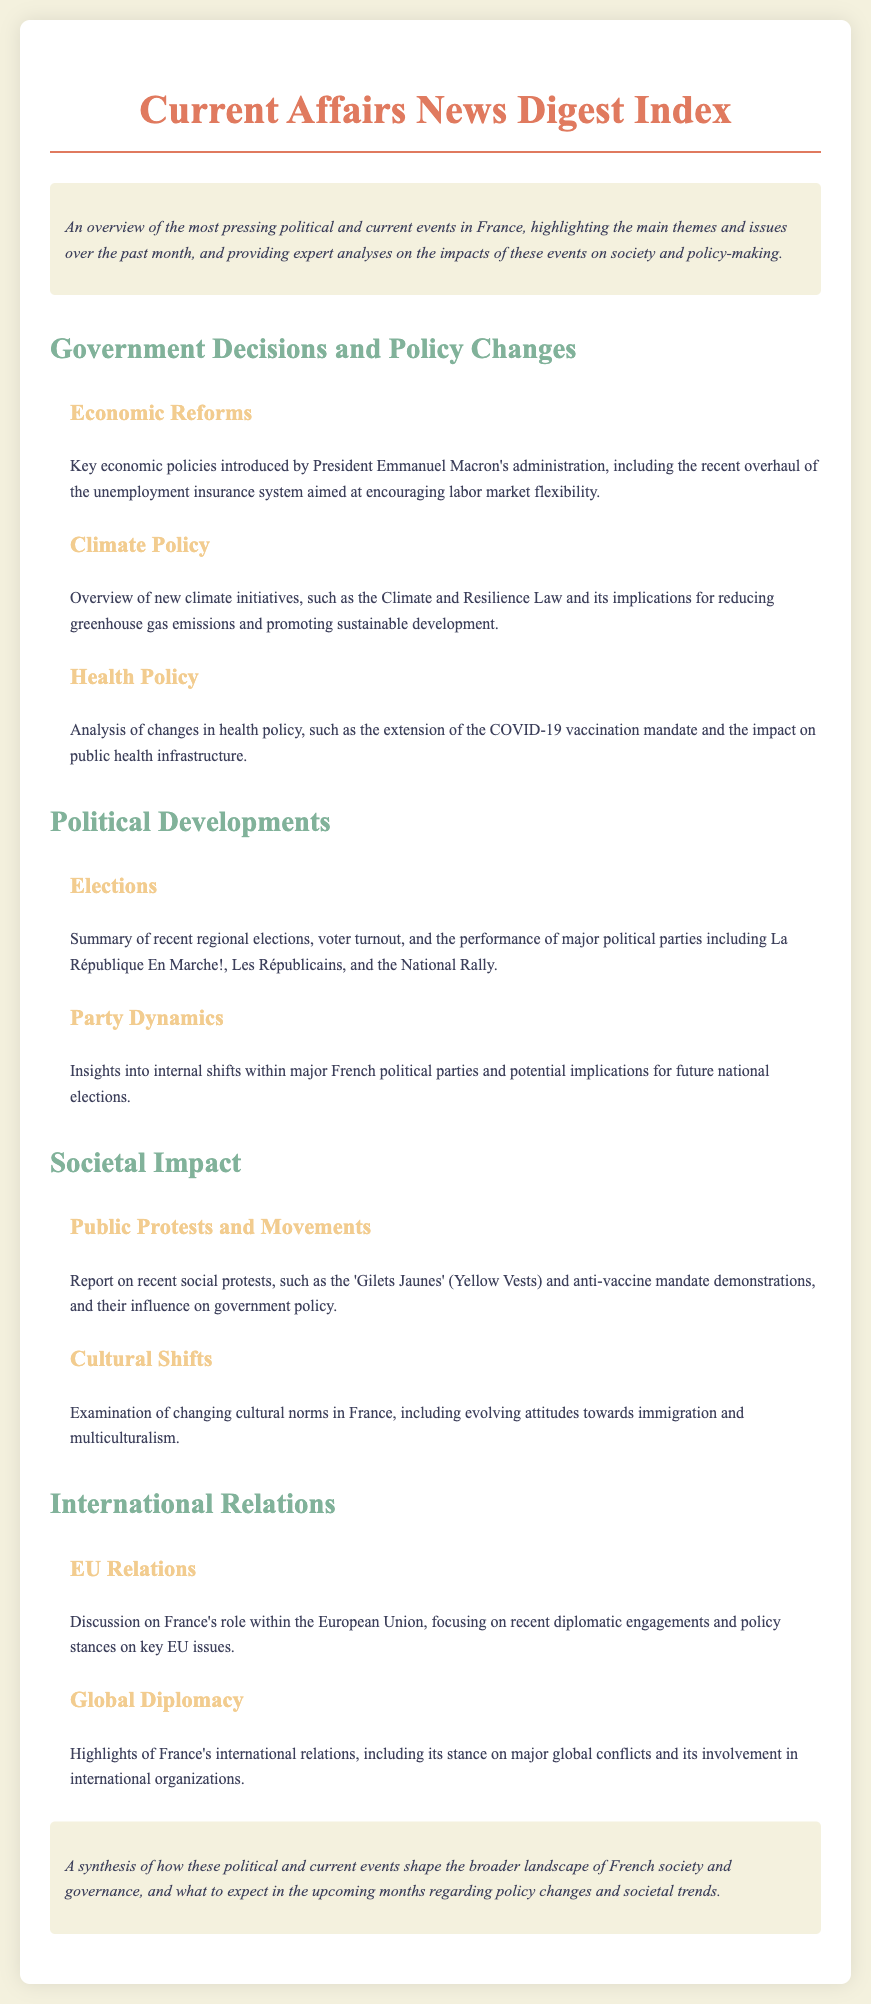what are the main themes of the document? The document provides an overview of significant political and current events in France, focusing on government decisions, societal impacts, and international relations.
Answer: political and current events who introduced the unemployment insurance overhaul? The overhaul of the unemployment insurance system was introduced by President Emmanuel Macron's administration.
Answer: President Emmanuel Macron what is the name of the law aimed at reducing greenhouse gas emissions? The Climate and Resilience Law is the initiative aimed at reducing greenhouse gas emissions.
Answer: Climate and Resilience Law what recent movements influenced government policy? Recent social protests influenced government policy, including the 'Gilets Jaunes' and anti-vaccine mandate demonstrations.
Answer: 'Gilets Jaunes' and anti-vaccine mandate demonstrations which parties were mentioned in relation to the recent elections? Major political parties mentioned include La République En Marche!, Les Républicains, and the National Rally.
Answer: La République En Marche!, Les Républicains, and the National Rally what are the key topics discussed under International Relations? The key topics discussed include France's role in the European Union and highlights of global diplomacy.
Answer: EU Relations and Global Diplomacy 